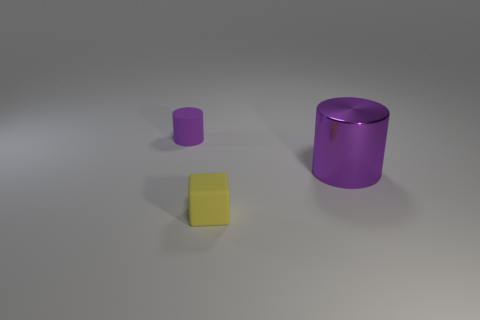Is the small cylinder the same color as the big thing?
Keep it short and to the point. Yes. There is a cylinder behind the metallic cylinder; is its color the same as the large metallic cylinder?
Provide a short and direct response. Yes. The big shiny object is what color?
Your response must be concise. Purple. There is a small thing behind the purple cylinder that is on the right side of the purple cylinder behind the large purple metallic thing; what is its shape?
Ensure brevity in your answer.  Cylinder. There is a tiny object that is to the right of the small rubber thing that is behind the purple shiny object; what is its material?
Offer a very short reply. Rubber. What shape is the small yellow object that is made of the same material as the tiny cylinder?
Offer a very short reply. Cube. Is there any other thing that has the same shape as the small yellow thing?
Ensure brevity in your answer.  No. There is a tiny block; how many tiny yellow rubber things are behind it?
Keep it short and to the point. 0. Are there any matte blocks?
Provide a succinct answer. Yes. There is a cylinder that is to the left of the cylinder in front of the small purple rubber cylinder that is behind the large object; what is its color?
Offer a terse response. Purple. 